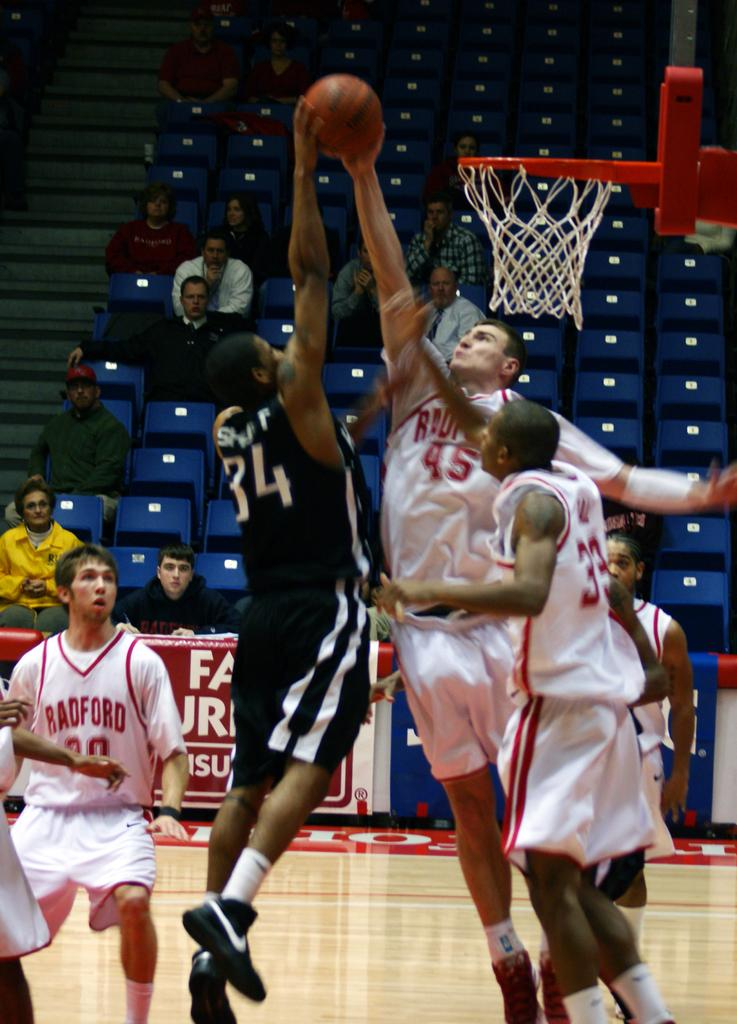What activity are the persons in the foreground of the image engaged in? The persons in the foreground of the image are playing basketball. What is the main feature of the foreground in the image? The basketball court is in the foreground of the image. What can be seen in the background of the image? There are chairs and stairs in the background of the image, as well as persons sitting. What is the chance of winning the lottery in the image? There is no mention of a lottery or any gambling activity in the image, so it is not possible to determine the chance of winning the lottery. 